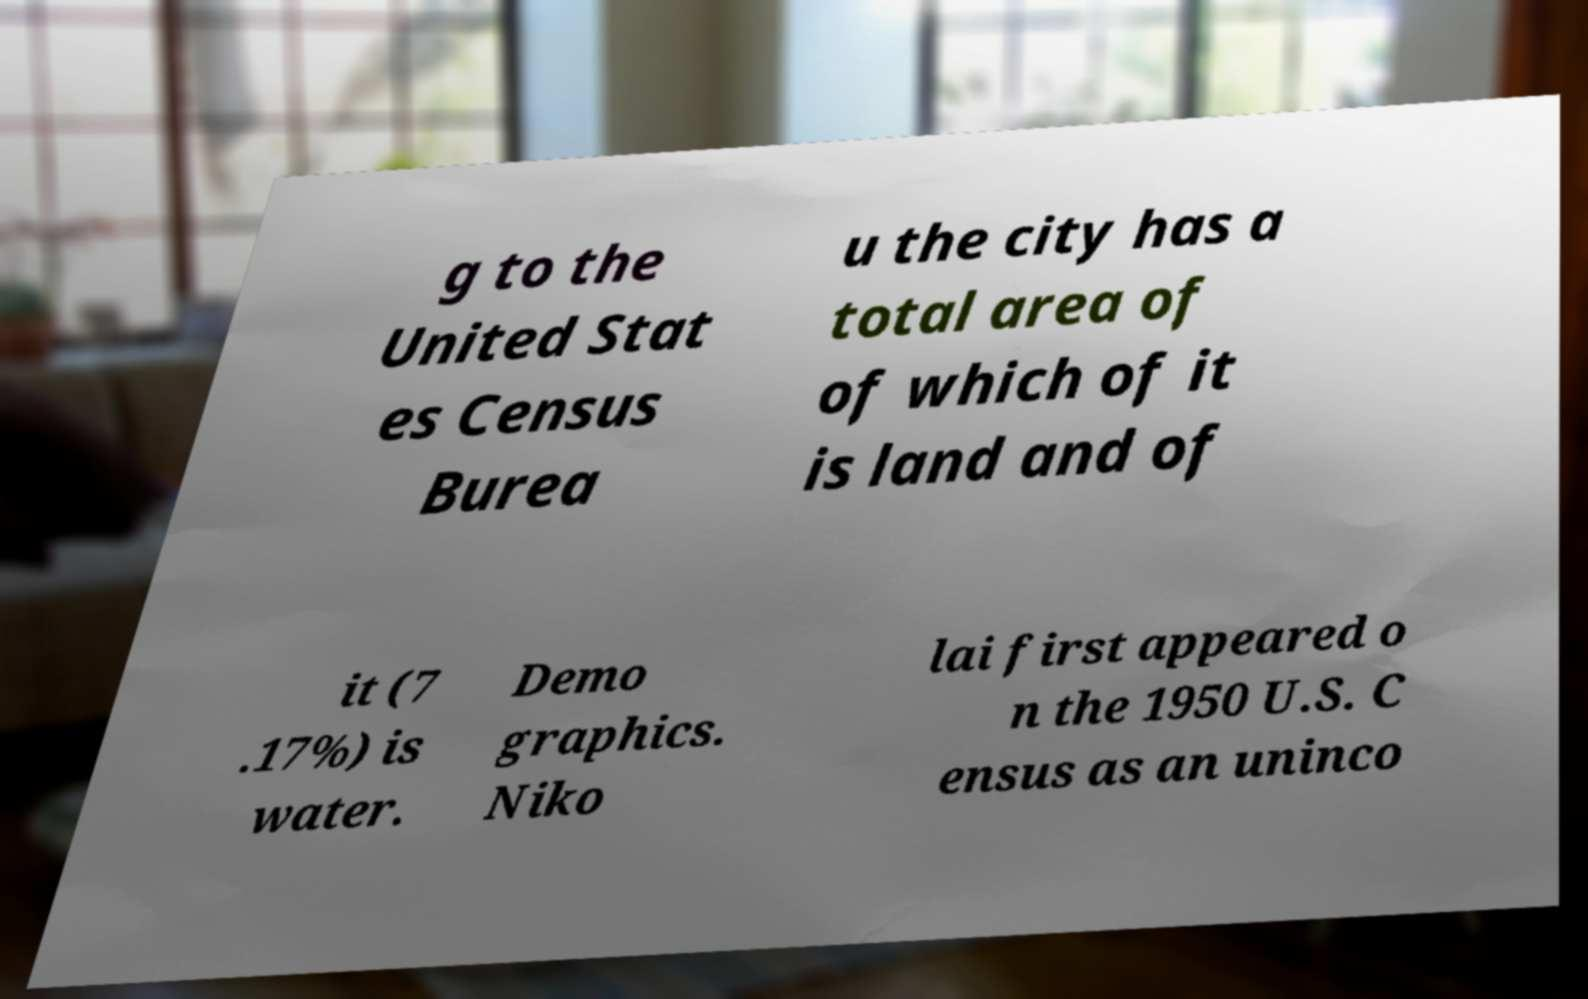There's text embedded in this image that I need extracted. Can you transcribe it verbatim? g to the United Stat es Census Burea u the city has a total area of of which of it is land and of it (7 .17%) is water. Demo graphics. Niko lai first appeared o n the 1950 U.S. C ensus as an uninco 